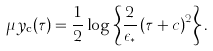Convert formula to latex. <formula><loc_0><loc_0><loc_500><loc_500>\mu y _ { \text {c} } ( \tau ) = \frac { 1 } { 2 } \log \left \{ \frac { 2 } { \epsilon _ { * } } \left ( \tau + c \right ) ^ { 2 } \right \} .</formula> 